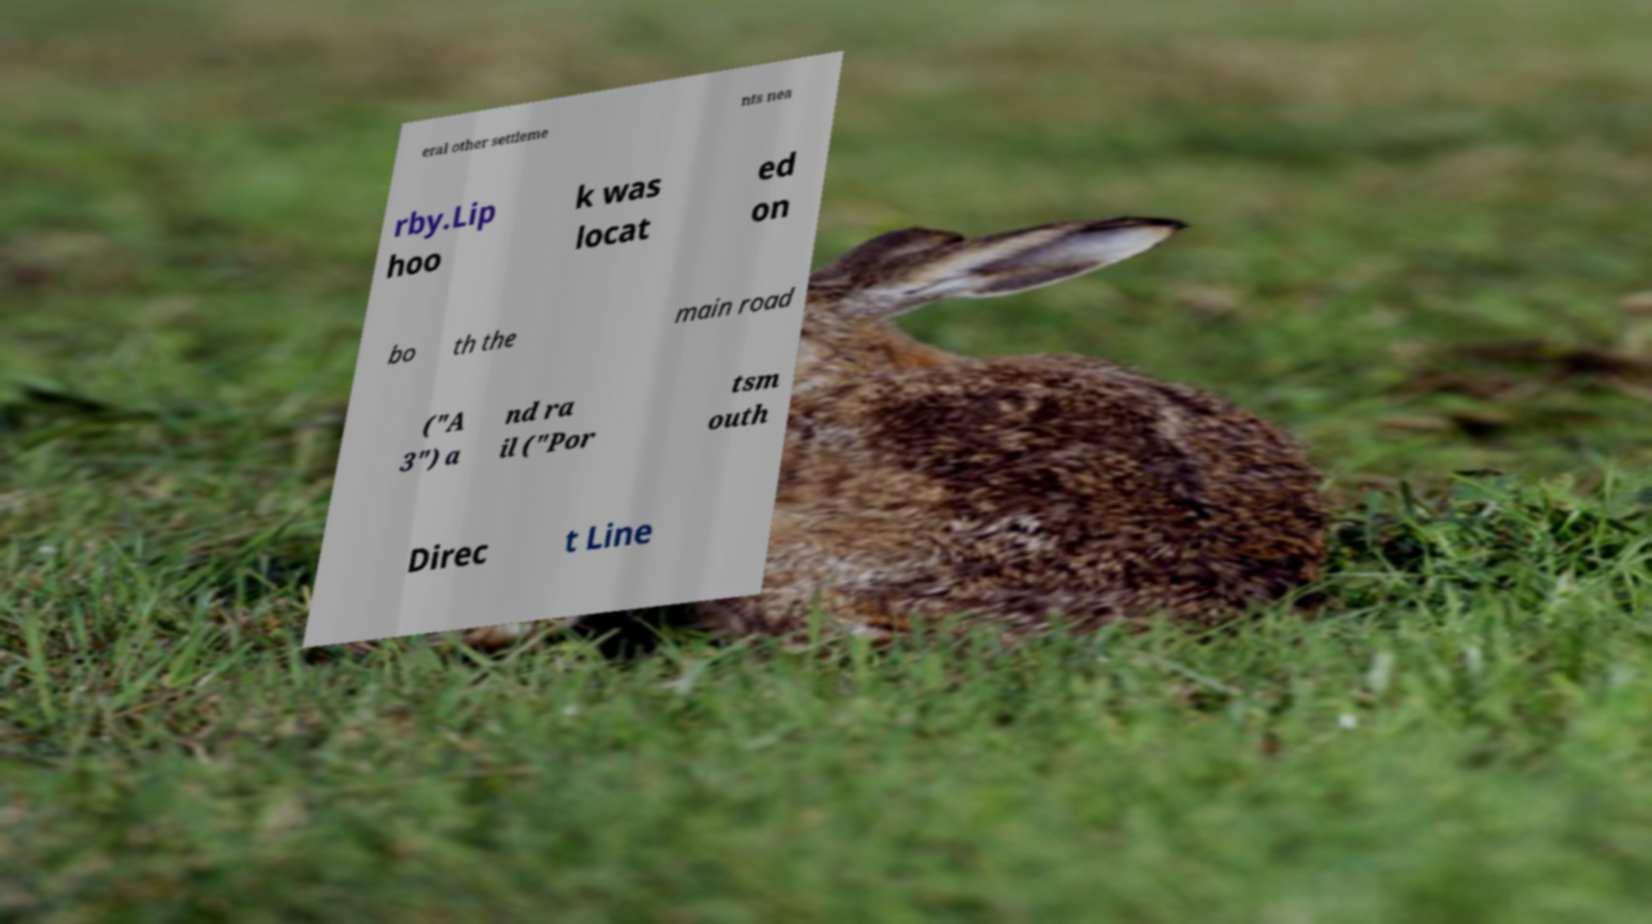For documentation purposes, I need the text within this image transcribed. Could you provide that? eral other settleme nts nea rby.Lip hoo k was locat ed on bo th the main road ("A 3") a nd ra il ("Por tsm outh Direc t Line 